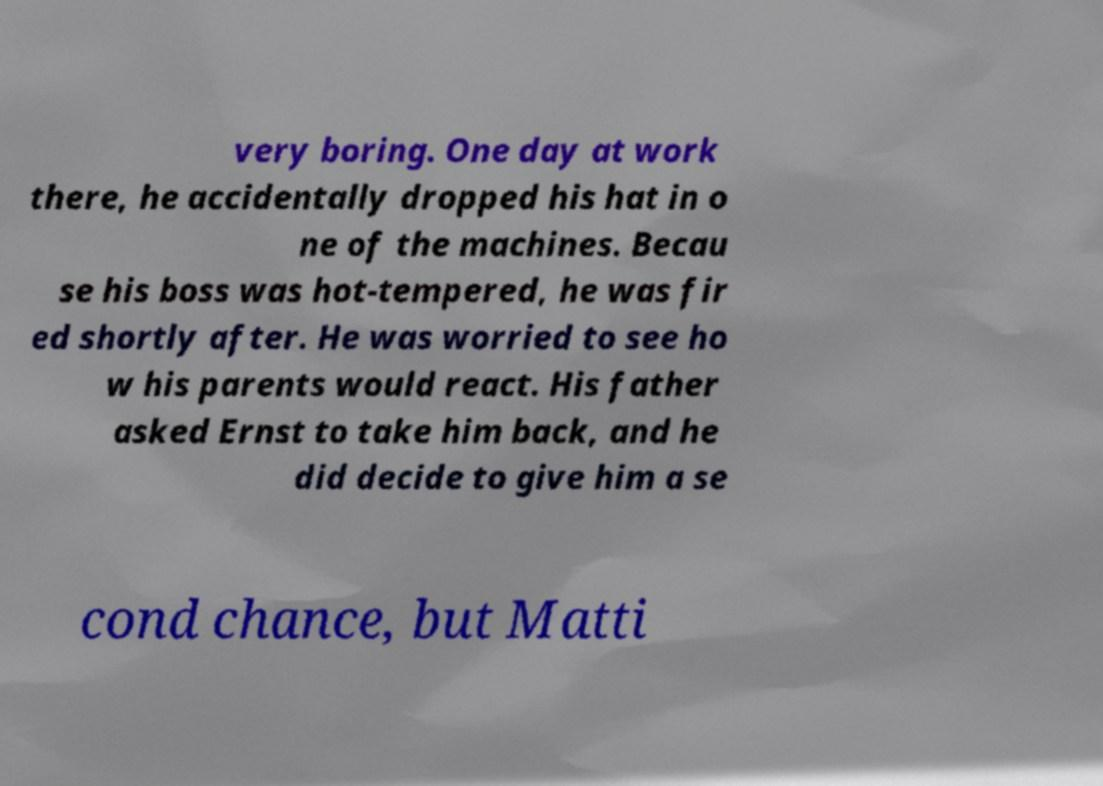Can you accurately transcribe the text from the provided image for me? very boring. One day at work there, he accidentally dropped his hat in o ne of the machines. Becau se his boss was hot-tempered, he was fir ed shortly after. He was worried to see ho w his parents would react. His father asked Ernst to take him back, and he did decide to give him a se cond chance, but Matti 